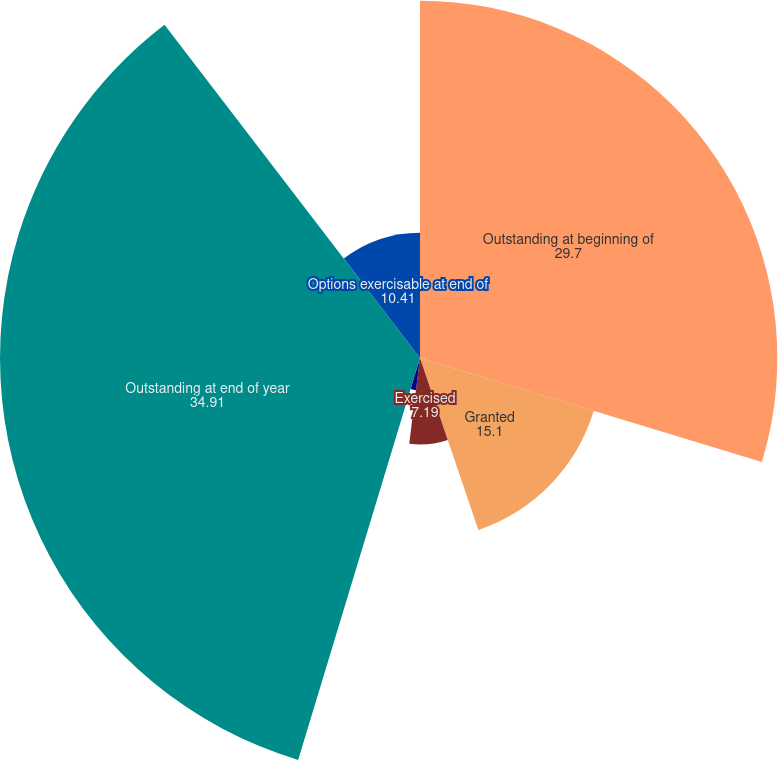Convert chart to OTSL. <chart><loc_0><loc_0><loc_500><loc_500><pie_chart><fcel>Outstanding at beginning of<fcel>Granted<fcel>Exercised<fcel>Canceled<fcel>Outstanding at end of year<fcel>Options exercisable at end of<nl><fcel>29.7%<fcel>15.1%<fcel>7.19%<fcel>2.7%<fcel>34.91%<fcel>10.41%<nl></chart> 